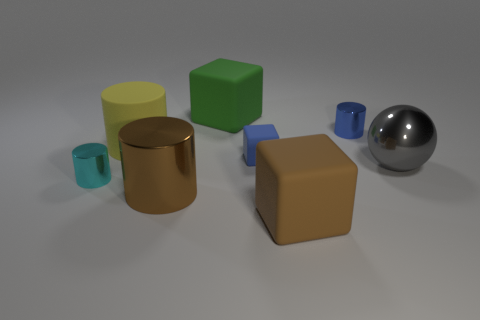Add 1 small rubber objects. How many objects exist? 9 Subtract all balls. How many objects are left? 7 Subtract 1 gray balls. How many objects are left? 7 Subtract all large blocks. Subtract all small cyan cylinders. How many objects are left? 5 Add 3 big gray shiny objects. How many big gray shiny objects are left? 4 Add 4 small blue metal cylinders. How many small blue metal cylinders exist? 5 